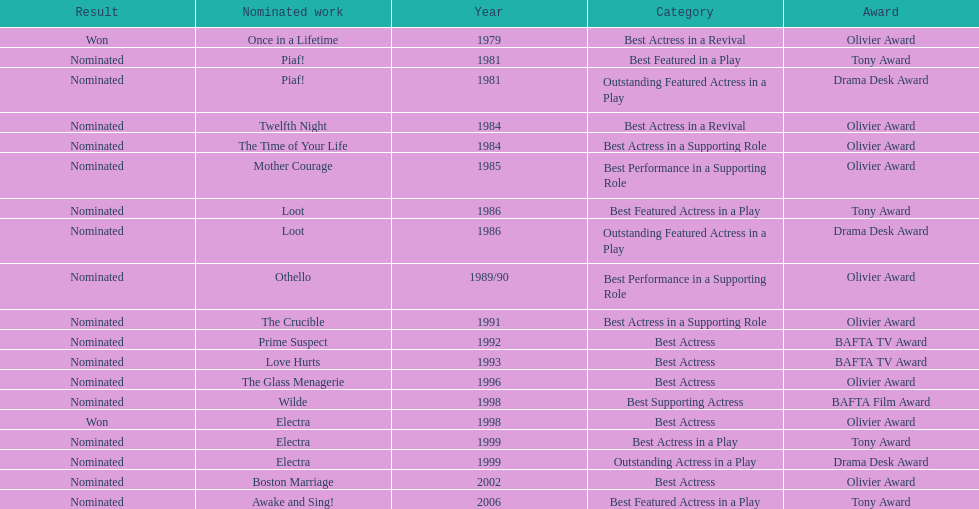What play was wanamaker nominated for best actress in a revival in 1984? Twelfth Night. 